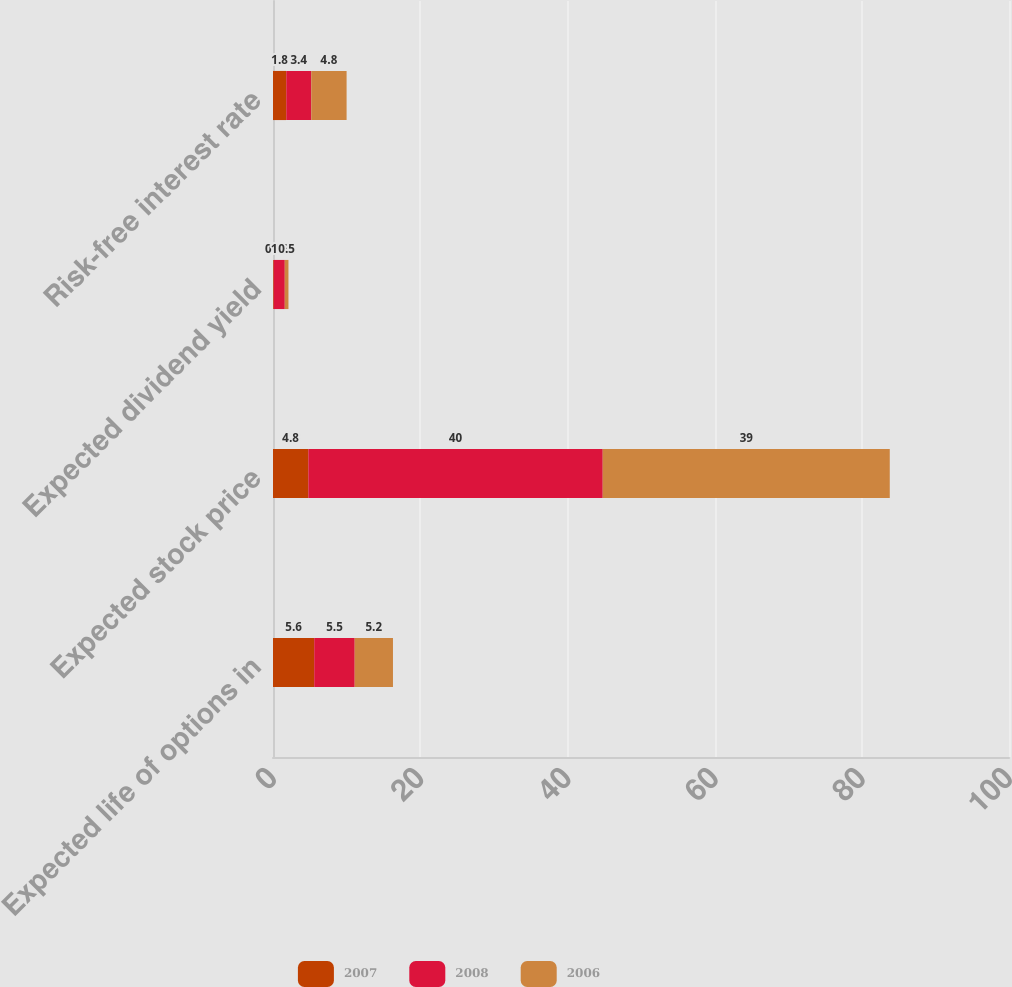Convert chart to OTSL. <chart><loc_0><loc_0><loc_500><loc_500><stacked_bar_chart><ecel><fcel>Expected life of options in<fcel>Expected stock price<fcel>Expected dividend yield<fcel>Risk-free interest rate<nl><fcel>2007<fcel>5.6<fcel>4.8<fcel>0.1<fcel>1.8<nl><fcel>2008<fcel>5.5<fcel>40<fcel>1.5<fcel>3.4<nl><fcel>2006<fcel>5.2<fcel>39<fcel>0.5<fcel>4.8<nl></chart> 